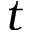<formula> <loc_0><loc_0><loc_500><loc_500>t</formula> 